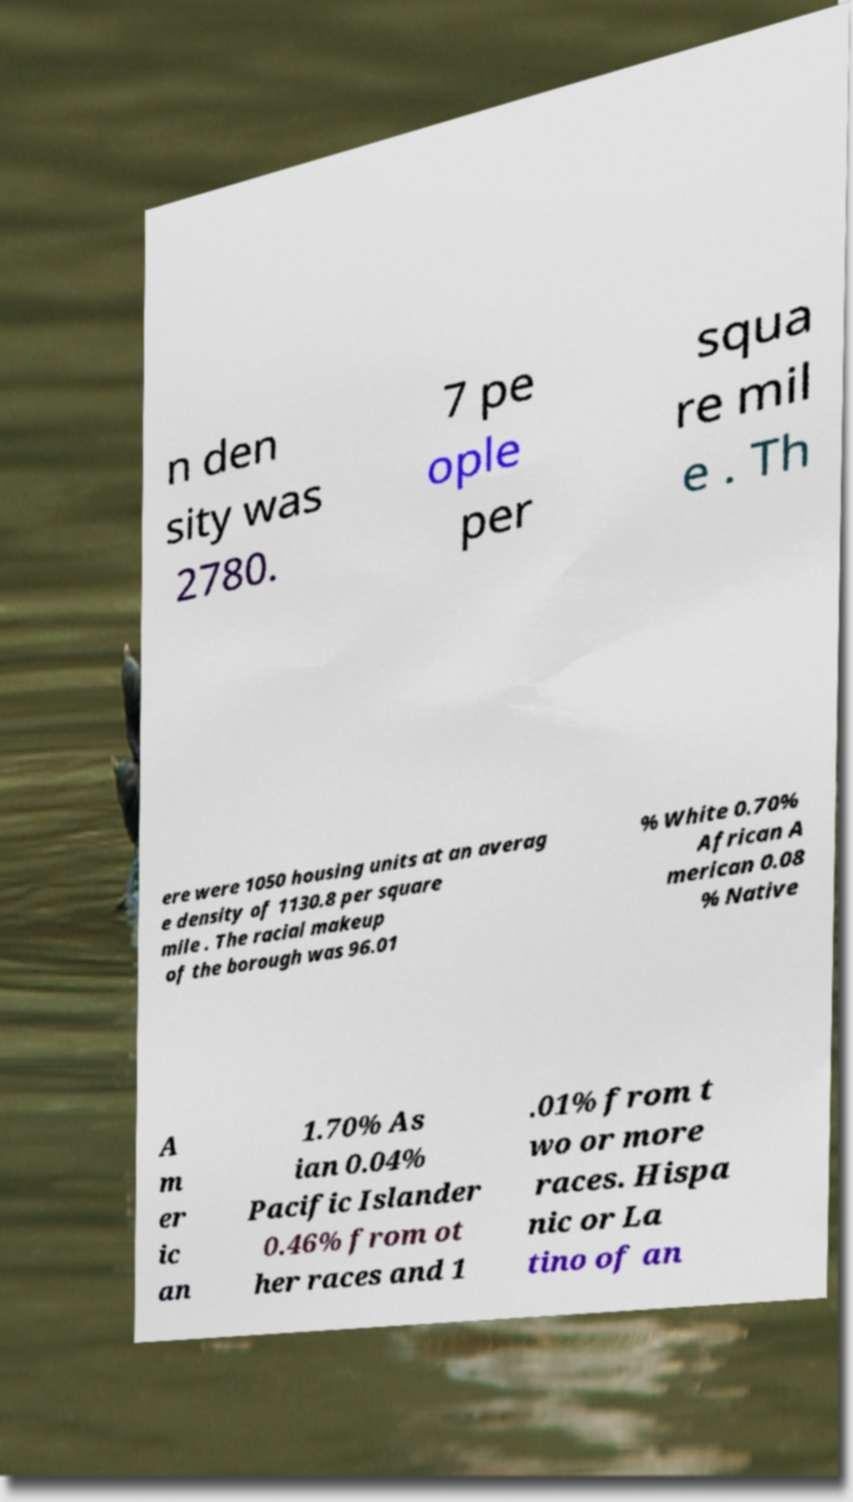I need the written content from this picture converted into text. Can you do that? n den sity was 2780. 7 pe ople per squa re mil e . Th ere were 1050 housing units at an averag e density of 1130.8 per square mile . The racial makeup of the borough was 96.01 % White 0.70% African A merican 0.08 % Native A m er ic an 1.70% As ian 0.04% Pacific Islander 0.46% from ot her races and 1 .01% from t wo or more races. Hispa nic or La tino of an 